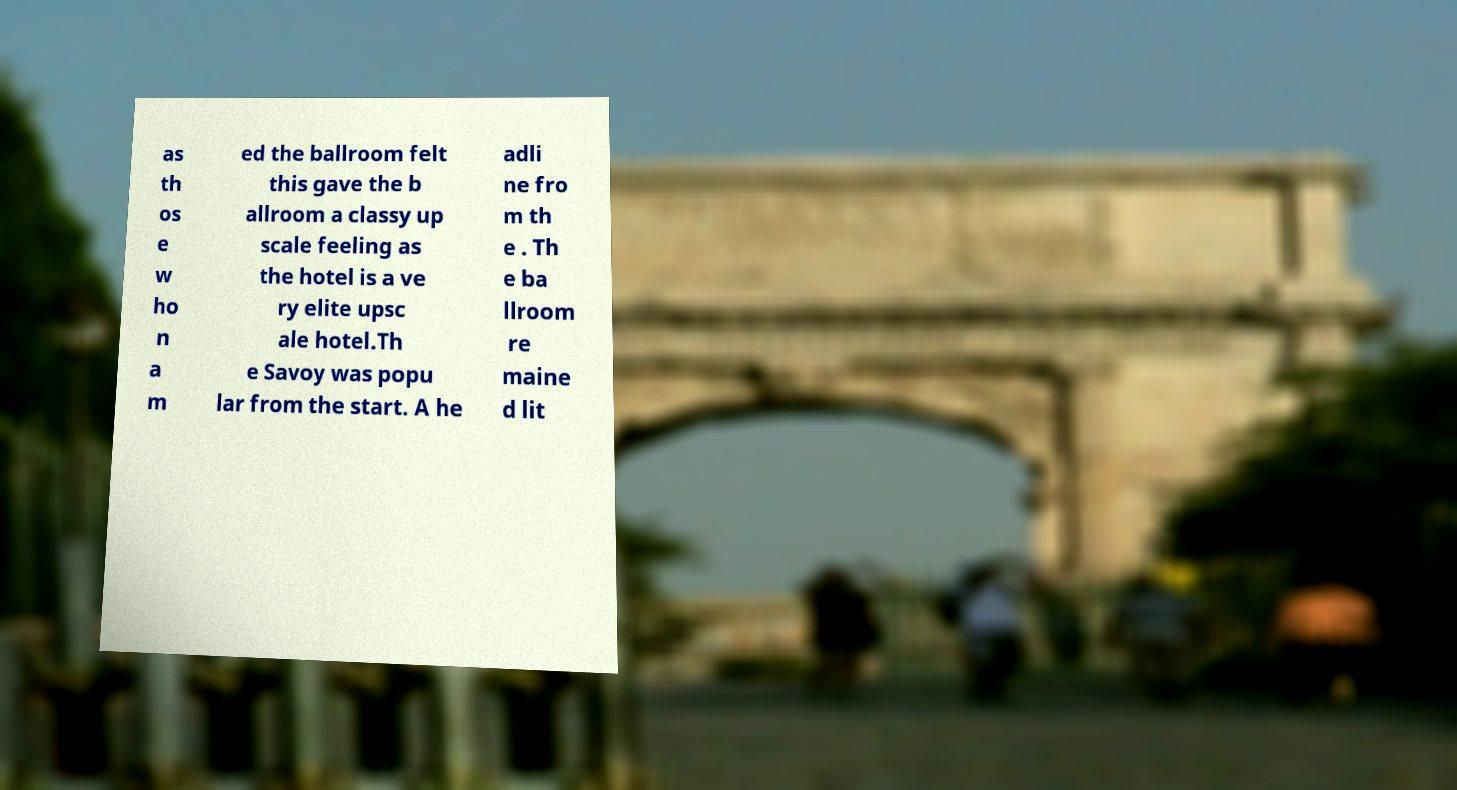What messages or text are displayed in this image? I need them in a readable, typed format. as th os e w ho n a m ed the ballroom felt this gave the b allroom a classy up scale feeling as the hotel is a ve ry elite upsc ale hotel.Th e Savoy was popu lar from the start. A he adli ne fro m th e . Th e ba llroom re maine d lit 